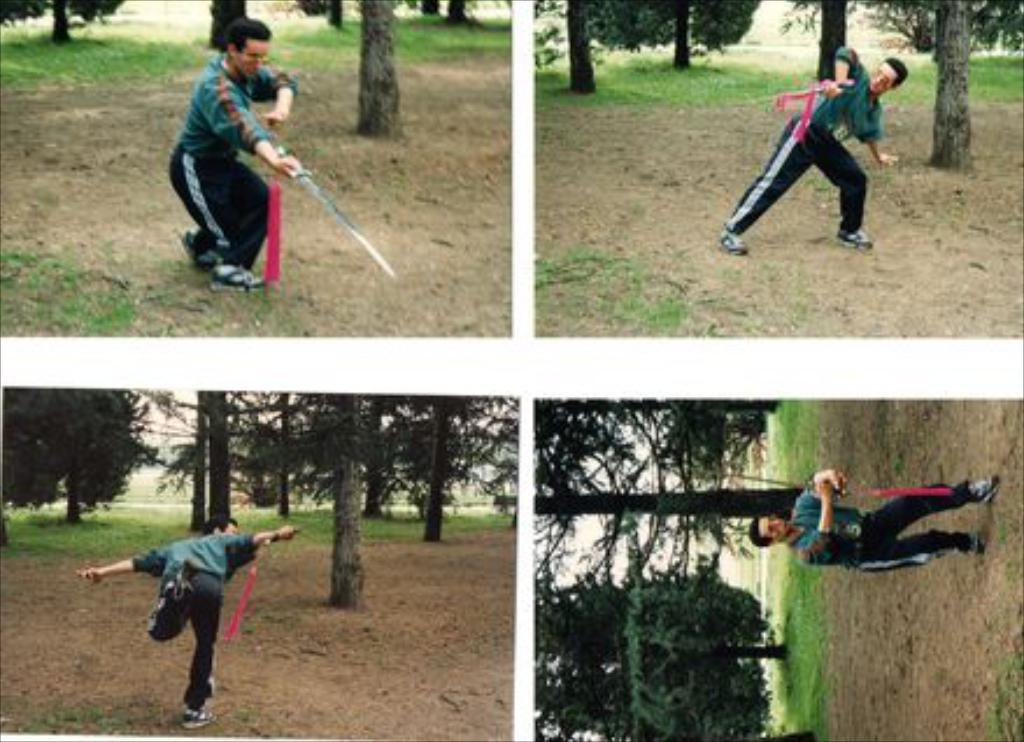How many images of a person are there in the image? There are four images of a person in the image. What is the person holding in their hand? The person is holding a sword in their hand. What is the person doing in the images? The person is practicing on the ground. What can be seen in the background of the images? There are trees and grass on the ground in the background. What type of mint is growing near the person in the image? There is no mint visible in the image; the background features trees and grass. 